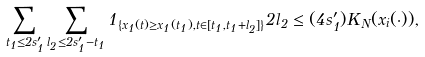Convert formula to latex. <formula><loc_0><loc_0><loc_500><loc_500>\sum _ { t _ { 1 } \leq 2 s ^ { \prime } _ { 1 } } \sum _ { l _ { 2 } \leq 2 s ^ { \prime } _ { 1 } - t _ { 1 } } 1 _ { \{ x _ { 1 } ( t ) \geq x _ { 1 } ( t _ { 1 } ) , t \in [ t _ { 1 } , t _ { 1 } + l _ { 2 } ] \} } 2 l _ { 2 } \leq ( 4 s ^ { \prime } _ { 1 } ) K _ { N } ( x _ { i } ( \cdot ) ) ,</formula> 